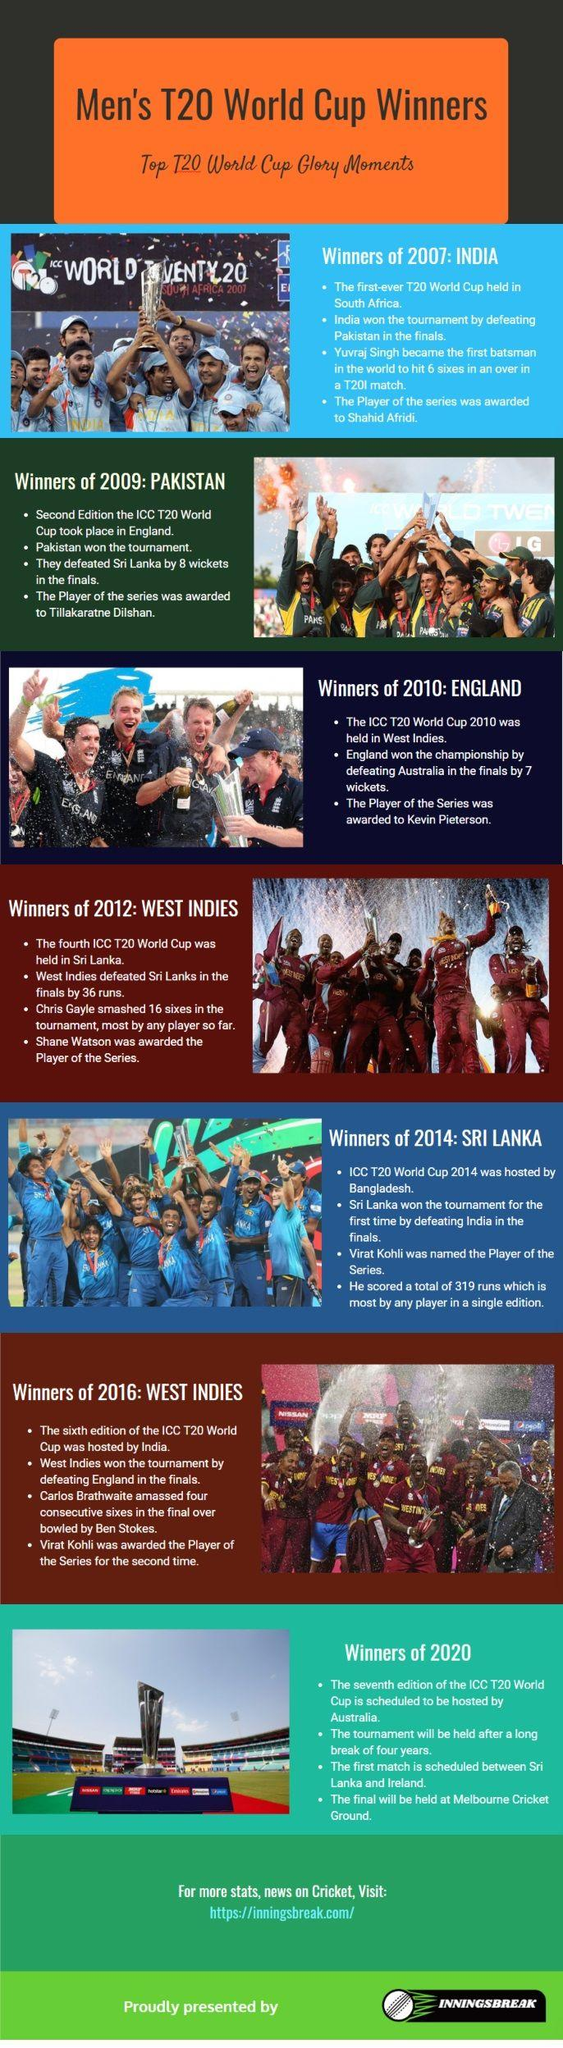Highlight a few significant elements in this photo. Six countries have won the T20 World Cup championship. 